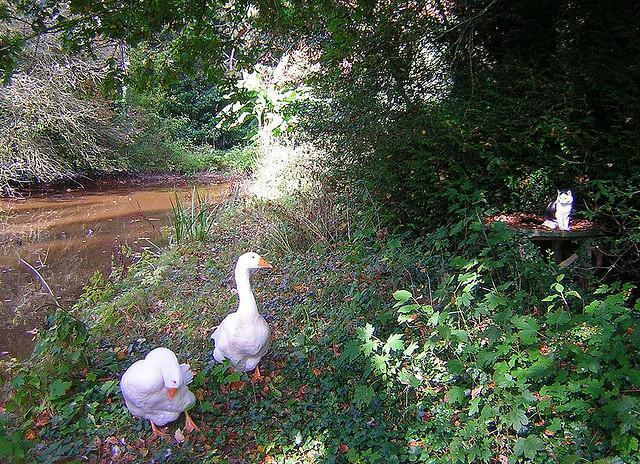How many different species of animals can be seen in this picture?
Give a very brief answer. 2. How many birds are visible?
Give a very brief answer. 2. 